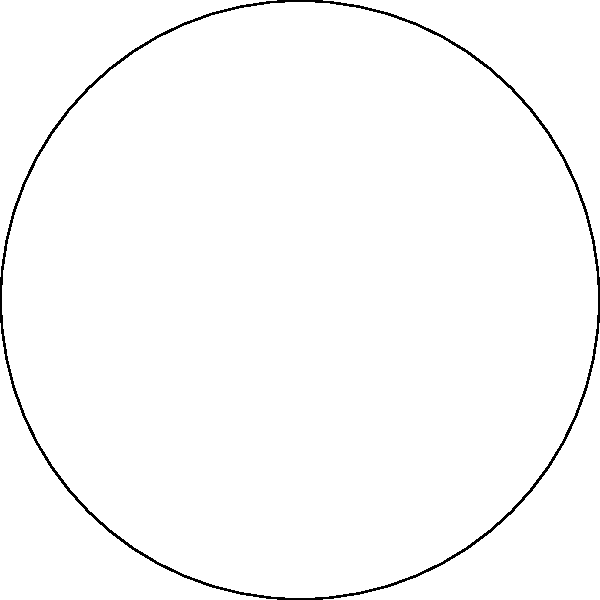Consider the cyclic group structure represented by the diagram, where each element corresponds to a major browser (Chrome, Firefox, Safari, and Edge). If the group operation represents the process of ensuring compatibility between consecutive browser versions, and we start with Chrome, how many operations are needed to return to Chrome while ensuring compatibility with all browsers? To solve this problem, we need to follow these steps:

1. Understand the group structure:
   - The diagram represents a cyclic group with 4 elements (Chrome, Firefox, Safari, and Edge).
   - The arrows indicate the direction of the group operation, moving from one browser to the next.

2. Identify the starting point:
   - We start with Chrome as specified in the question.

3. Count the operations:
   - From Chrome to Firefox: 1 operation
   - From Firefox to Safari: 1 operation
   - From Safari to Edge: 1 operation
   - From Edge back to Chrome: 1 operation

4. Sum up the total operations:
   - Total operations = 1 + 1 + 1 + 1 = 4

5. Verify the result:
   - After 4 operations, we have ensured compatibility with all browsers and returned to the starting point (Chrome).

Therefore, 4 operations are needed to return to Chrome while ensuring compatibility with all browsers in the cyclic group structure.
Answer: 4 operations 